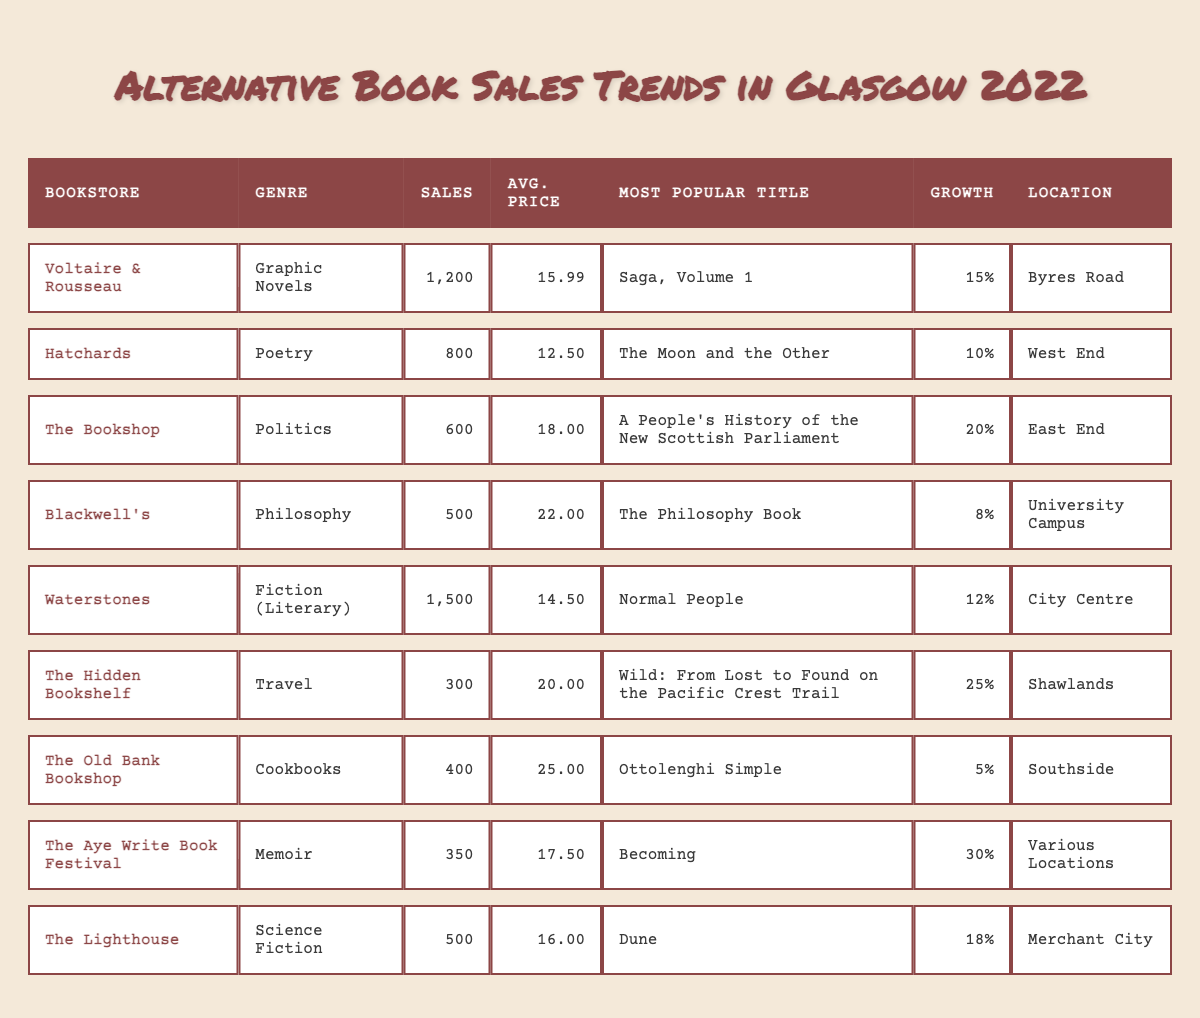What is the most popular title sold at Waterstones? The table indicates that the most popular title at Waterstones is "Normal People."
Answer: Normal People Which bookstore had the highest sales in 2022? The sales figures show Waterstones had the highest sales at 1,500 units.
Answer: Waterstones What was the average price of books sold at The Hidden Bookshelf? The average price listed for The Hidden Bookshelf is £20.00.
Answer: £20.00 How many more graphic novels were sold at Voltaire & Rousseau compared to science fiction books at The Lighthouse? Voltaire & Rousseau sold 1,200 graphic novels, and The Lighthouse sold 500 science fiction books. The difference in sales is 1,200 - 500 = 700.
Answer: 700 What percentage growth did cookbook sales experience at The Old Bank Bookshop? The table shows an 8% growth in sales for cookbooks at The Old Bank Bookshop.
Answer: 8% Is the average price of poetry books at Hatchards lower than the average price of politics books at The Bookshop? The average price of poetry books at Hatchards is £12.50, and the average price of politics books at The Bookshop is £18.00. Since £12.50 is less than £18.00, the statement is true.
Answer: Yes What is the total number of sales for travel and memoir genres combined? The Hidden Bookshelf (travel) sold 300 books and The Aye Write Book Festival (memoir) sold 350 books. Thus, the total sales are 300 + 350 = 650.
Answer: 650 Which genre experienced the highest sales growth in 2022? The table indicates that the memoir genre at The Aye Write Book Festival had the highest growth at 30%.
Answer: Memoir What is the average sales figure across all bookstores listed in the table? The total sales are 1,200 + 800 + 600 + 500 + 1,500 + 300 + 400 + 350 + 500 = 6,850. There are 9 bookstores, so the average is 6,850 / 9 = approximately 761.11.
Answer: 761.11 Did Blackwell's sell more philosophy books than The Old Bank Bookshop sold cookbooks? Blackwell's sold 500 philosophy books while The Old Bank Bookshop sold 400 cookbooks. Therefore, Blackwell's sold more books.
Answer: Yes How many locations were represented in the sales data? The table lists seven unique locations where the bookstores are situated (Byres Road, West End, East End, University Campus, City Centre, Shawlands, Various Locations, Merchant City). Counting these gives 8 distinct locations.
Answer: 8 